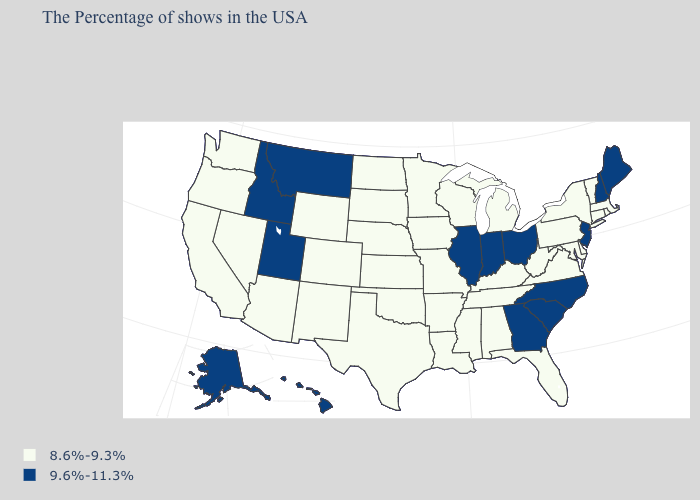What is the lowest value in states that border Texas?
Concise answer only. 8.6%-9.3%. Name the states that have a value in the range 8.6%-9.3%?
Quick response, please. Massachusetts, Rhode Island, Vermont, Connecticut, New York, Delaware, Maryland, Pennsylvania, Virginia, West Virginia, Florida, Michigan, Kentucky, Alabama, Tennessee, Wisconsin, Mississippi, Louisiana, Missouri, Arkansas, Minnesota, Iowa, Kansas, Nebraska, Oklahoma, Texas, South Dakota, North Dakota, Wyoming, Colorado, New Mexico, Arizona, Nevada, California, Washington, Oregon. What is the highest value in the USA?
Write a very short answer. 9.6%-11.3%. Which states have the lowest value in the West?
Be succinct. Wyoming, Colorado, New Mexico, Arizona, Nevada, California, Washington, Oregon. Name the states that have a value in the range 9.6%-11.3%?
Write a very short answer. Maine, New Hampshire, New Jersey, North Carolina, South Carolina, Ohio, Georgia, Indiana, Illinois, Utah, Montana, Idaho, Alaska, Hawaii. Which states hav the highest value in the MidWest?
Be succinct. Ohio, Indiana, Illinois. Name the states that have a value in the range 9.6%-11.3%?
Be succinct. Maine, New Hampshire, New Jersey, North Carolina, South Carolina, Ohio, Georgia, Indiana, Illinois, Utah, Montana, Idaho, Alaska, Hawaii. What is the value of Delaware?
Be succinct. 8.6%-9.3%. What is the highest value in states that border Kentucky?
Quick response, please. 9.6%-11.3%. Among the states that border Wyoming , does Montana have the lowest value?
Give a very brief answer. No. Name the states that have a value in the range 8.6%-9.3%?
Write a very short answer. Massachusetts, Rhode Island, Vermont, Connecticut, New York, Delaware, Maryland, Pennsylvania, Virginia, West Virginia, Florida, Michigan, Kentucky, Alabama, Tennessee, Wisconsin, Mississippi, Louisiana, Missouri, Arkansas, Minnesota, Iowa, Kansas, Nebraska, Oklahoma, Texas, South Dakota, North Dakota, Wyoming, Colorado, New Mexico, Arizona, Nevada, California, Washington, Oregon. What is the value of Vermont?
Concise answer only. 8.6%-9.3%. Among the states that border Arkansas , which have the lowest value?
Give a very brief answer. Tennessee, Mississippi, Louisiana, Missouri, Oklahoma, Texas. Name the states that have a value in the range 9.6%-11.3%?
Quick response, please. Maine, New Hampshire, New Jersey, North Carolina, South Carolina, Ohio, Georgia, Indiana, Illinois, Utah, Montana, Idaho, Alaska, Hawaii. What is the value of Maryland?
Short answer required. 8.6%-9.3%. 